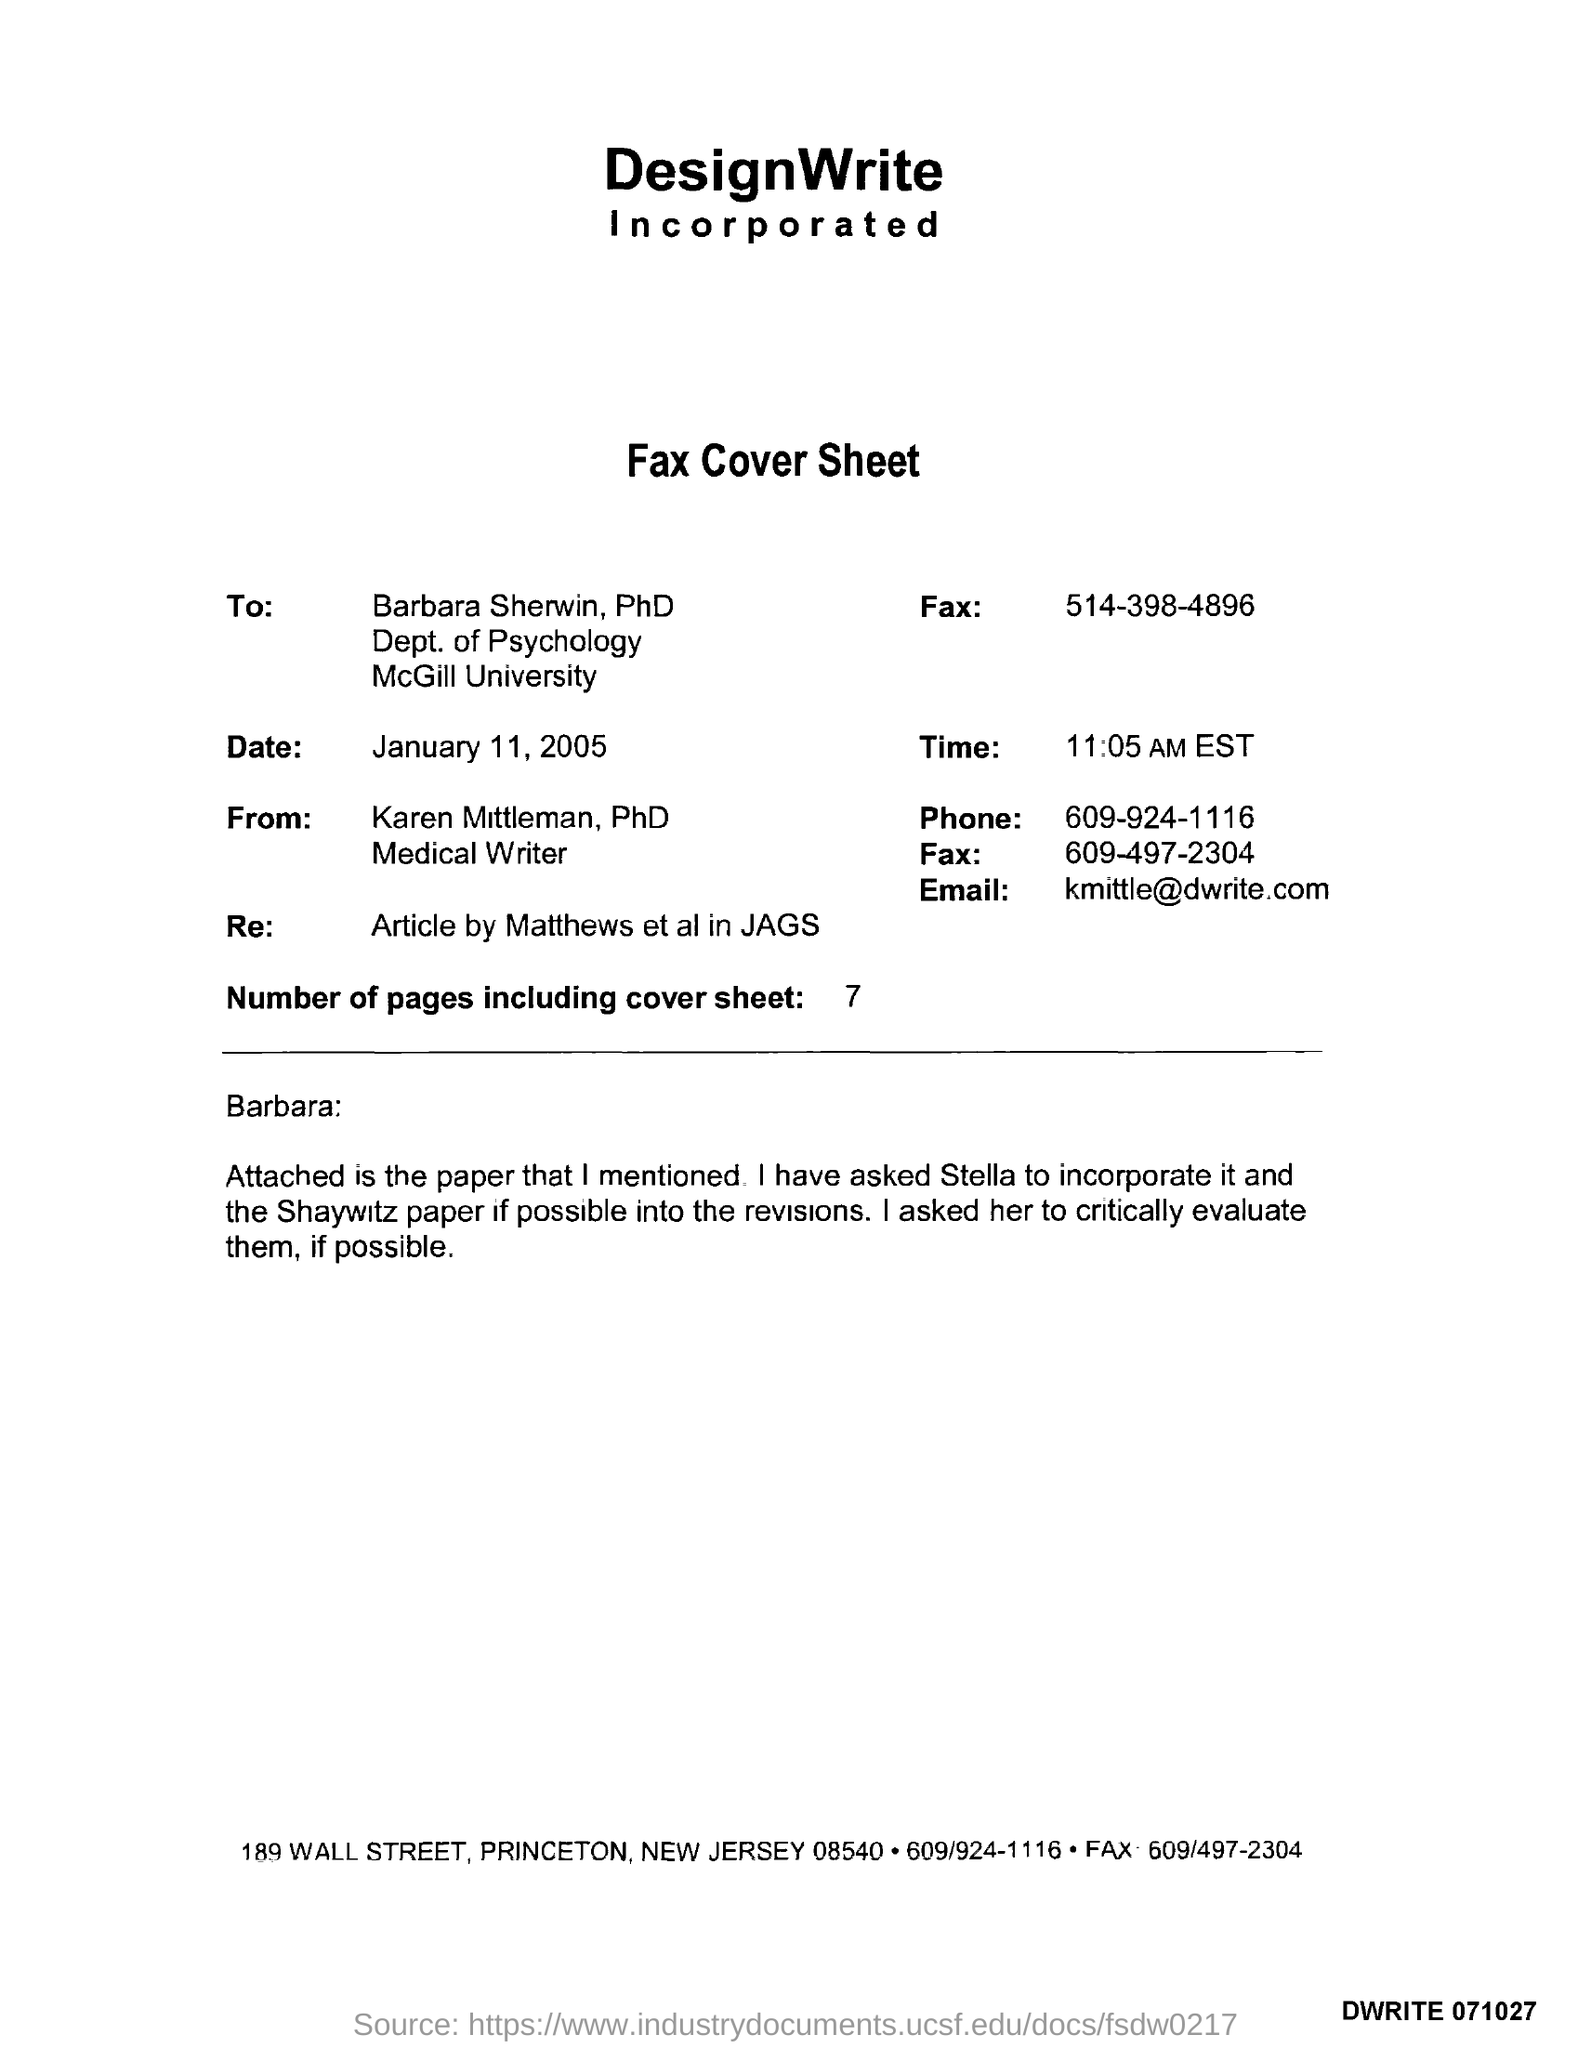What kind of document is this?
Provide a short and direct response. Fax Cover Sheet. Who is the sender of the Fax?
Provide a short and direct response. Karen Mittleman. Who is the receiver of the Fax?
Provide a short and direct response. Barbara Sherwin, PhD. In which University, Barbara Sherwin, PhD works?
Your answer should be compact. McGill University. What is the Fax No of Barbara Sherwin, PhD?
Keep it short and to the point. 514-398-4896. How many pages are there in the fax including cover sheet?
Ensure brevity in your answer.  7. What is the date mentioned in the fax cover sheet?
Your answer should be very brief. January 11, 2005. What is the time mentioned in fax cover sheet?
Keep it short and to the point. 11:05 AM. What is the designation of Karen Mittleman, PhD?
Offer a very short reply. Medical Writer. 